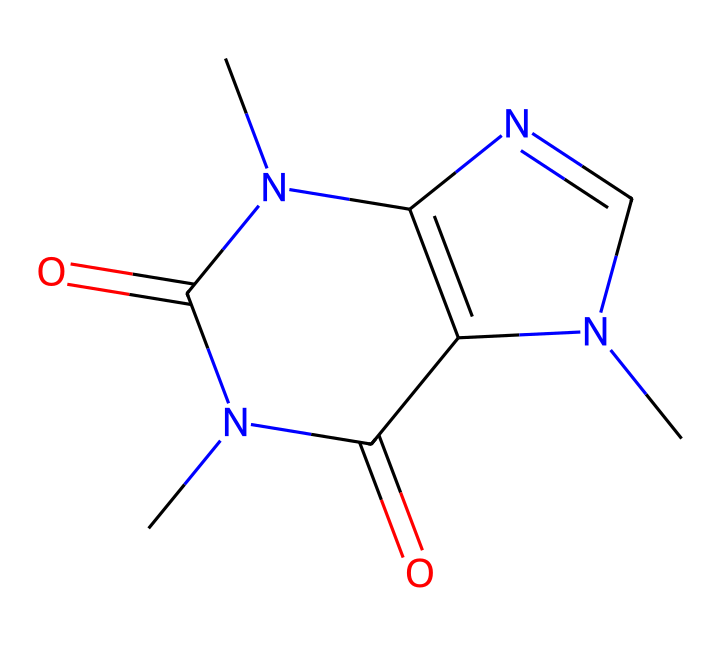What is the molecular formula of caffeine? By analyzing the SMILES representation, we can count each type of atom present. In the structure, we find there are 8 carbon atoms, 10 hydrogen atoms, and 4 nitrogen atoms, which gives us the molecular formula C8H10N4O2.
Answer: C8H10N4O2 How many nitrogen atoms are in caffeine? From the SMILES representation, we can see that there are 4 nitrogen atoms indicated in the structure.
Answer: 4 What type of compound is caffeine classified as? Caffeine contains nitrogen and is derived from plants, placing it in the category of alkaloids, which are known for their stimulant effects.
Answer: alkaloid What is the total number of rings in the caffeine structure? By examining the connections in the SMILES, we observe that there are 2 interconnected ring structures present in the molecule.
Answer: 2 What functional groups are present in caffeine? The structure contains amine groups (from the presence of nitrogen atoms connected to carbon) and carbonyl groups (from the carbon atoms double-bonded to oxygen), indicating the variety of functional groups.
Answer: amine and carbonyl What is the primary biological effect of caffeine? The structure suggests its role as a central nervous system stimulant, commonly known for enhancing alertness and reducing fatigue, which is its primary biological effect.
Answer: stimulant 